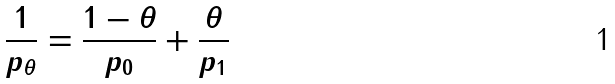<formula> <loc_0><loc_0><loc_500><loc_500>\frac { 1 } { p _ { \theta } } = \frac { 1 - \theta } { p _ { 0 } } + \frac { \theta } { p _ { 1 } }</formula> 